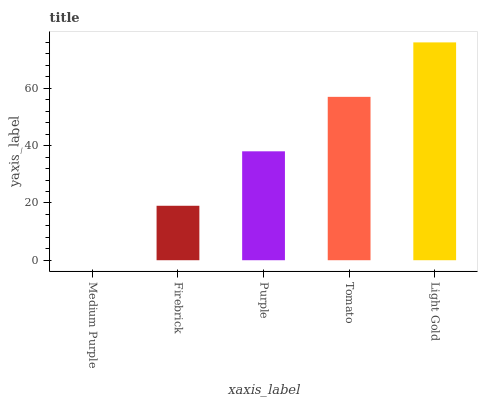Is Medium Purple the minimum?
Answer yes or no. Yes. Is Light Gold the maximum?
Answer yes or no. Yes. Is Firebrick the minimum?
Answer yes or no. No. Is Firebrick the maximum?
Answer yes or no. No. Is Firebrick greater than Medium Purple?
Answer yes or no. Yes. Is Medium Purple less than Firebrick?
Answer yes or no. Yes. Is Medium Purple greater than Firebrick?
Answer yes or no. No. Is Firebrick less than Medium Purple?
Answer yes or no. No. Is Purple the high median?
Answer yes or no. Yes. Is Purple the low median?
Answer yes or no. Yes. Is Firebrick the high median?
Answer yes or no. No. Is Light Gold the low median?
Answer yes or no. No. 